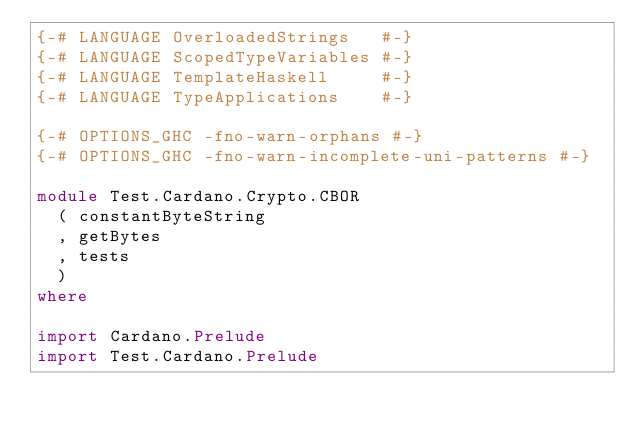Convert code to text. <code><loc_0><loc_0><loc_500><loc_500><_Haskell_>{-# LANGUAGE OverloadedStrings   #-}
{-# LANGUAGE ScopedTypeVariables #-}
{-# LANGUAGE TemplateHaskell     #-}
{-# LANGUAGE TypeApplications    #-}

{-# OPTIONS_GHC -fno-warn-orphans #-}
{-# OPTIONS_GHC -fno-warn-incomplete-uni-patterns #-}

module Test.Cardano.Crypto.CBOR
  ( constantByteString
  , getBytes
  , tests
  )
where

import Cardano.Prelude
import Test.Cardano.Prelude
</code> 